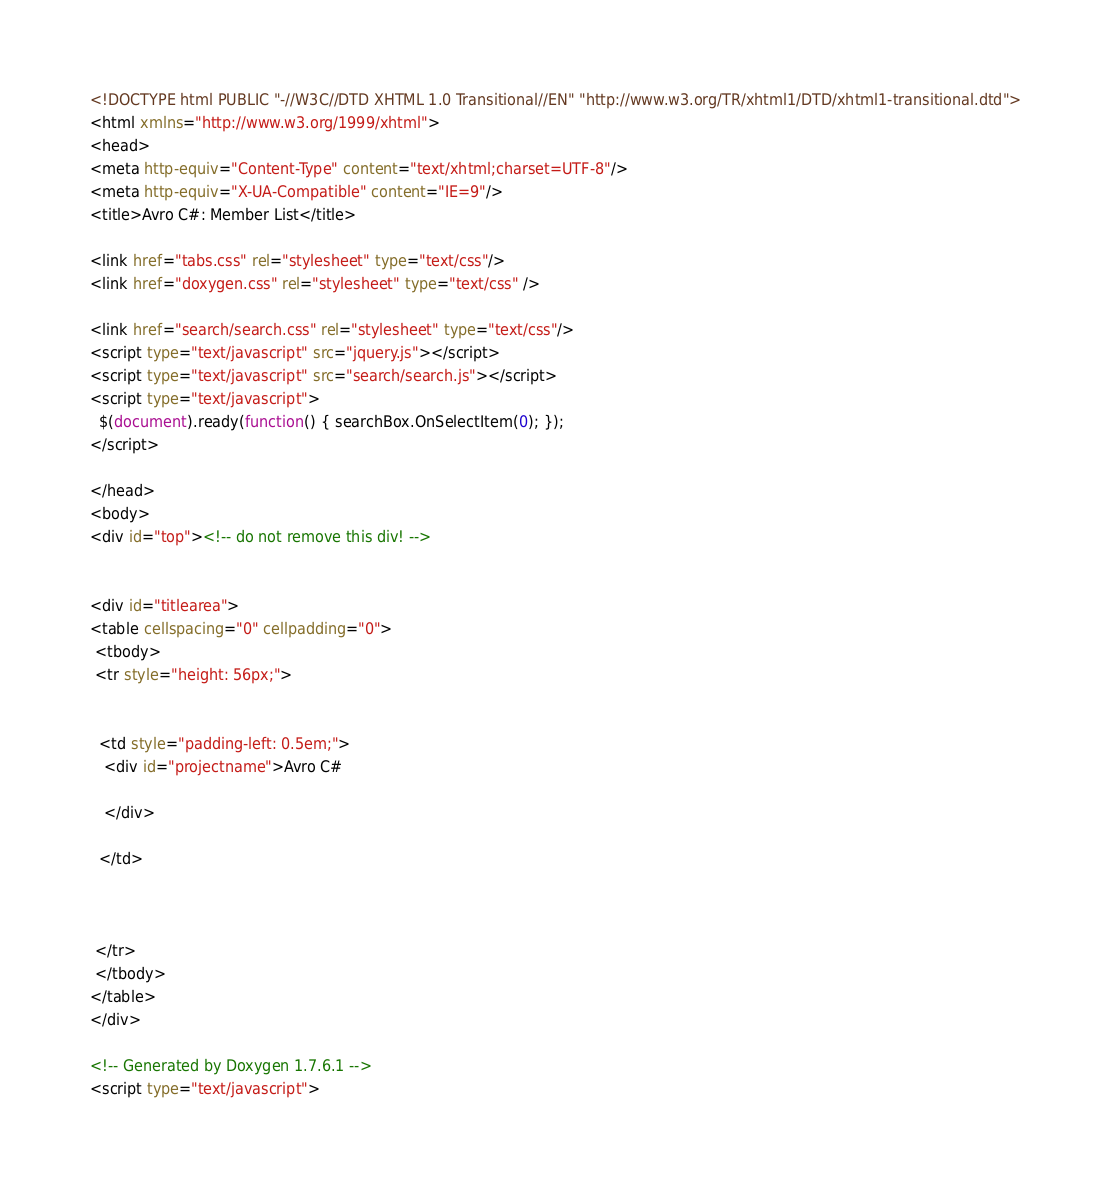<code> <loc_0><loc_0><loc_500><loc_500><_HTML_><!DOCTYPE html PUBLIC "-//W3C//DTD XHTML 1.0 Transitional//EN" "http://www.w3.org/TR/xhtml1/DTD/xhtml1-transitional.dtd">
<html xmlns="http://www.w3.org/1999/xhtml">
<head>
<meta http-equiv="Content-Type" content="text/xhtml;charset=UTF-8"/>
<meta http-equiv="X-UA-Compatible" content="IE=9"/>
<title>Avro C#: Member List</title>

<link href="tabs.css" rel="stylesheet" type="text/css"/>
<link href="doxygen.css" rel="stylesheet" type="text/css" />

<link href="search/search.css" rel="stylesheet" type="text/css"/>
<script type="text/javascript" src="jquery.js"></script>
<script type="text/javascript" src="search/search.js"></script>
<script type="text/javascript">
  $(document).ready(function() { searchBox.OnSelectItem(0); });
</script>

</head>
<body>
<div id="top"><!-- do not remove this div! -->


<div id="titlearea">
<table cellspacing="0" cellpadding="0">
 <tbody>
 <tr style="height: 56px;">
  
  
  <td style="padding-left: 0.5em;">
   <div id="projectname">Avro C#
   
   </div>
   
  </td>
  
  
  
 </tr>
 </tbody>
</table>
</div>

<!-- Generated by Doxygen 1.7.6.1 -->
<script type="text/javascript"></code> 